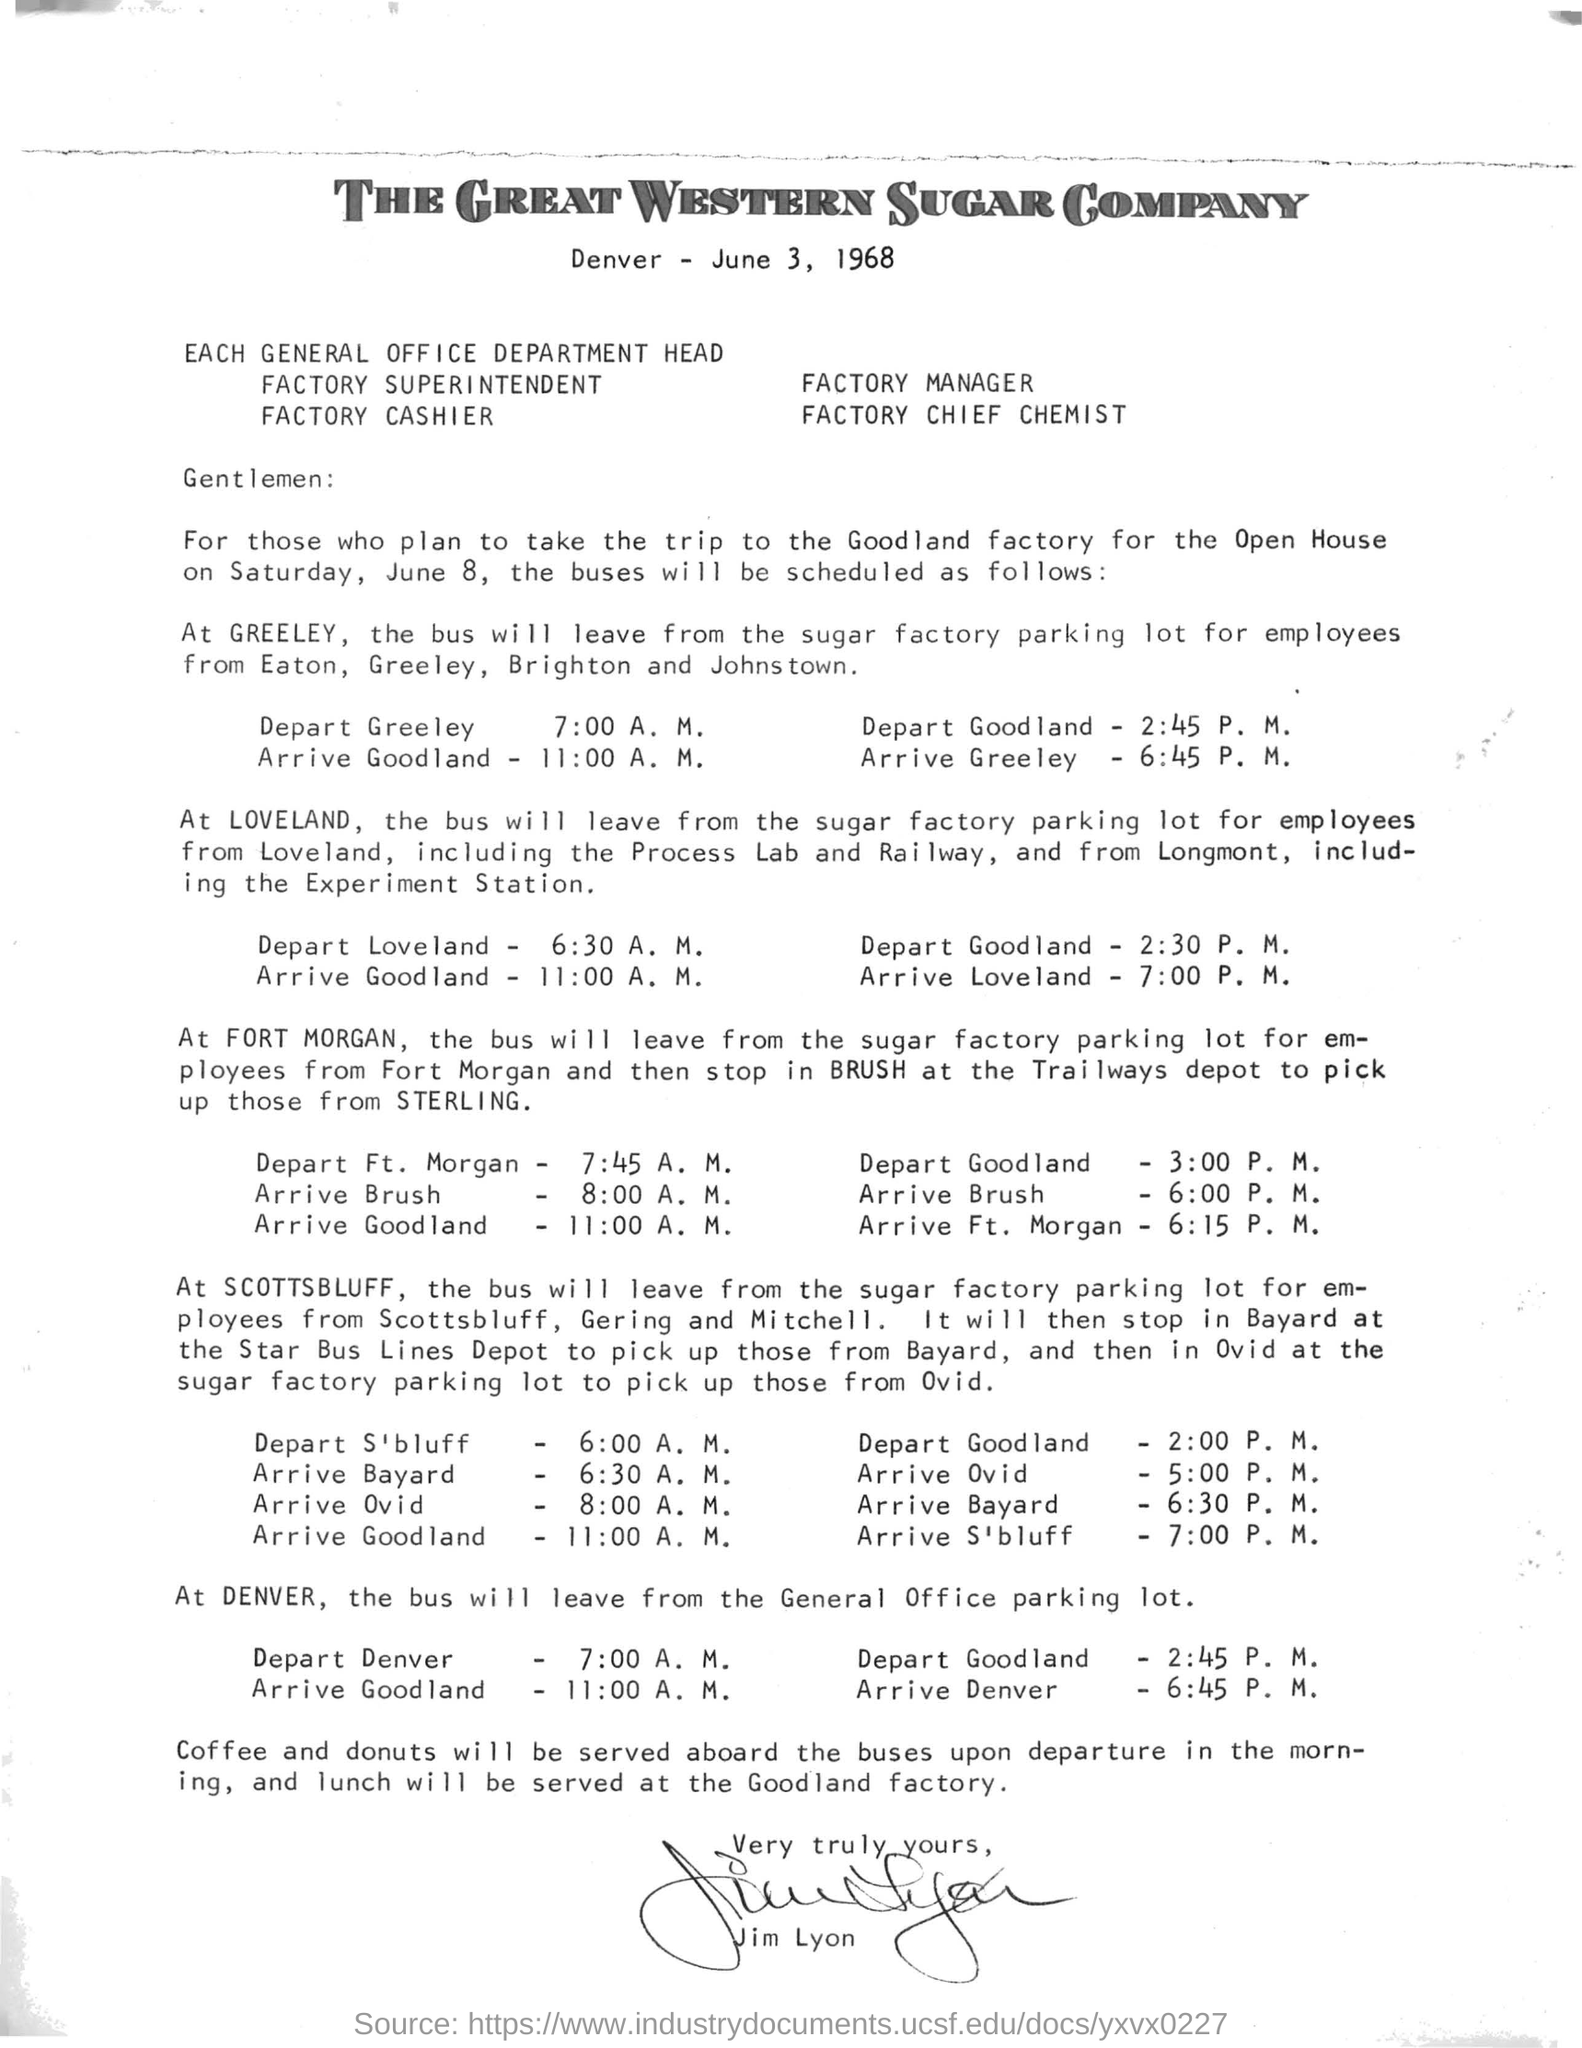Mention a couple of crucial points in this snapshot. The letter is dated on June 3, 1968. The trip to the Goodland factory for the Open House took place on Saturday, June 8. The stop before Ft. Morgan is Brush. The bus departs from the General Office parking lot in Denver. Based on the provided bus schedules, Fort Morgan is the starting station that is closest to the Goodland factory. 